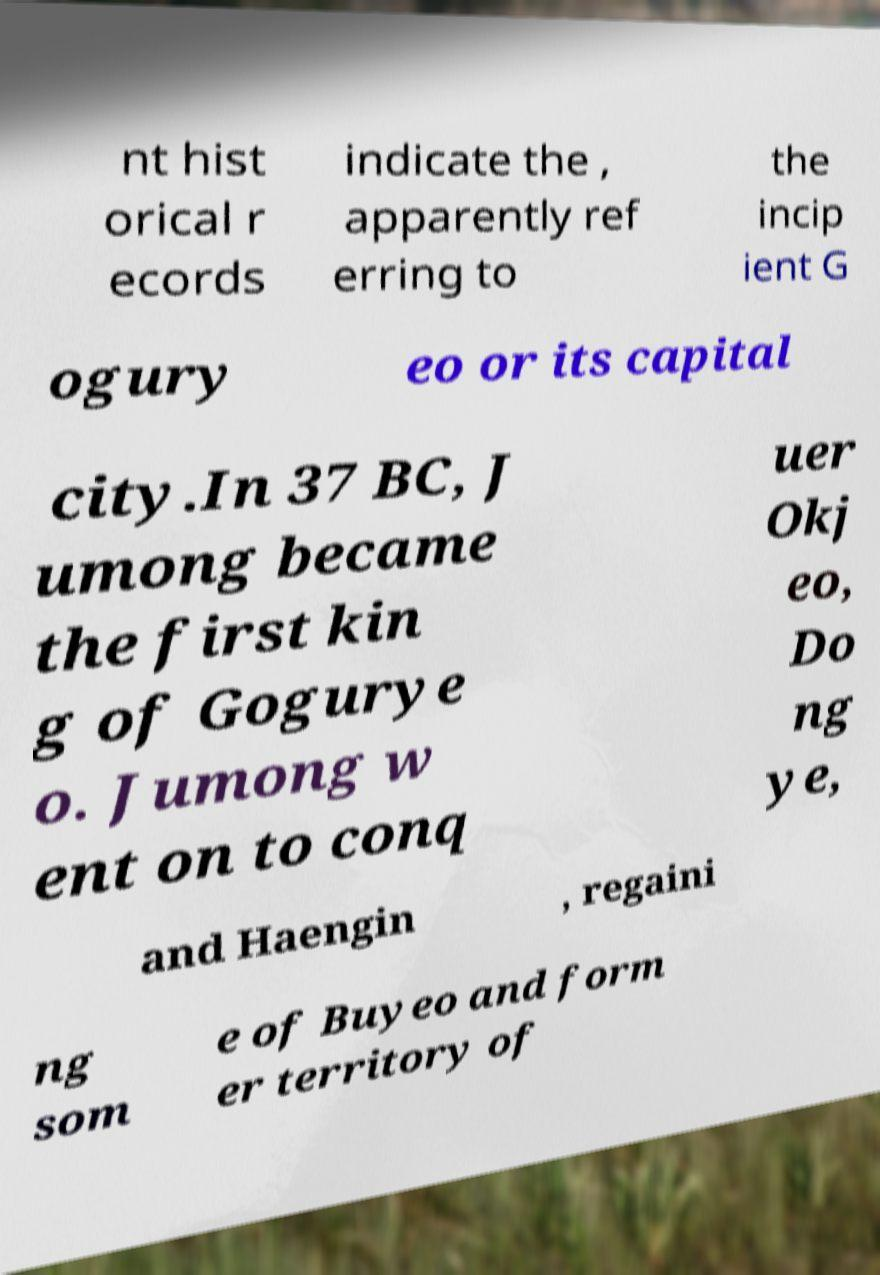For documentation purposes, I need the text within this image transcribed. Could you provide that? nt hist orical r ecords indicate the , apparently ref erring to the incip ient G ogury eo or its capital city.In 37 BC, J umong became the first kin g of Gogurye o. Jumong w ent on to conq uer Okj eo, Do ng ye, and Haengin , regaini ng som e of Buyeo and form er territory of 